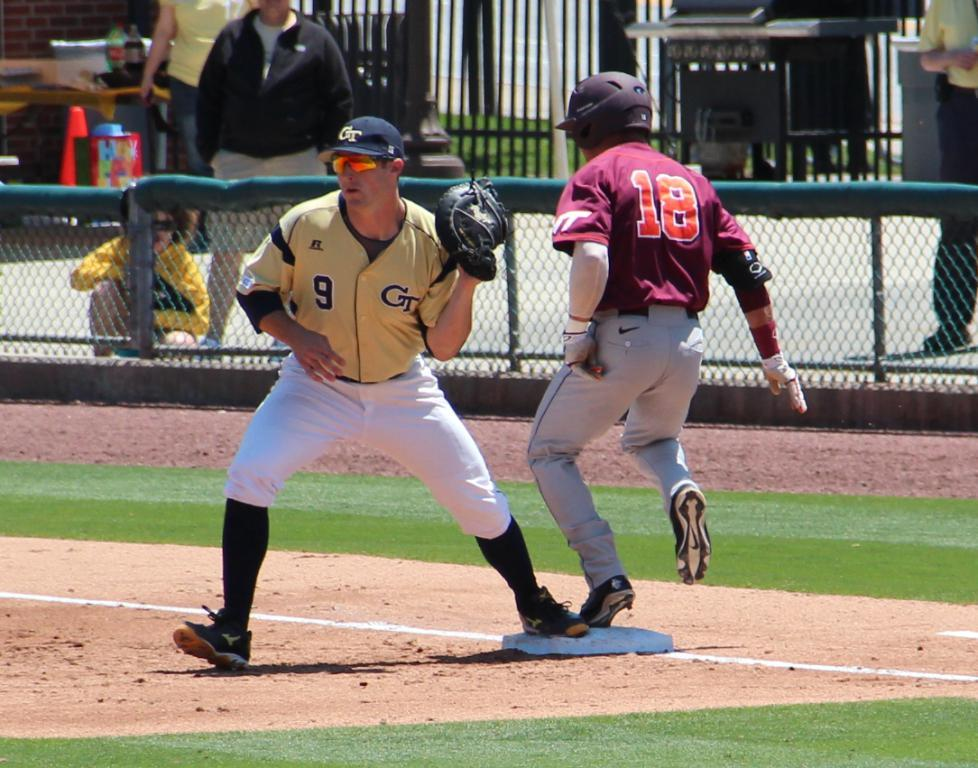<image>
Offer a succinct explanation of the picture presented. virginia tech player number 18 running to the base that georgia tech player number 9 is standing at 